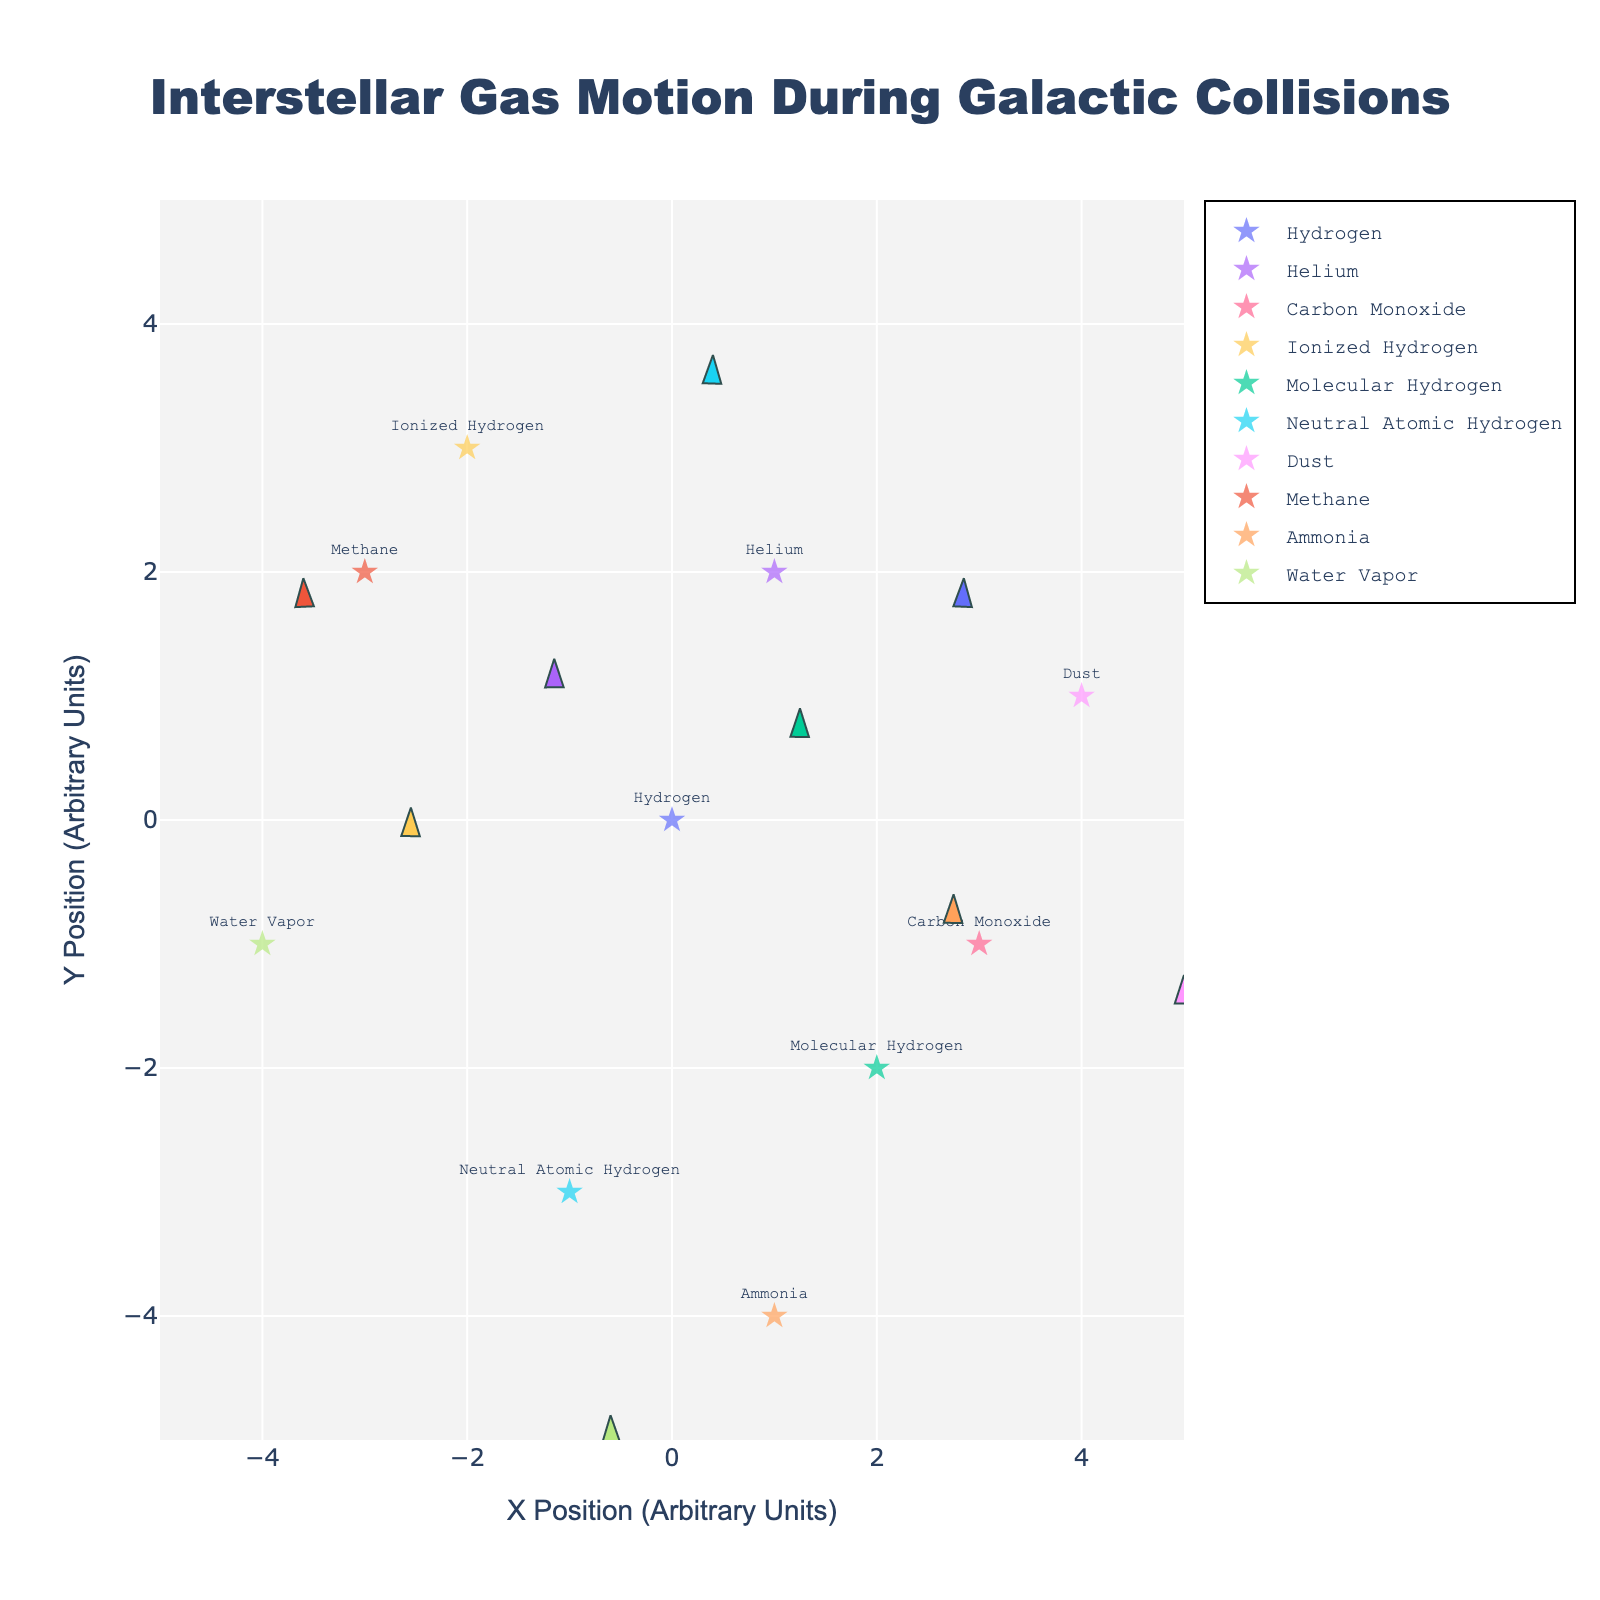What is the title of the figure? The title is located at the top center of the figure, which provides a brief description of the content being displayed. The title reads "Interstellar Gas Motion During Galactic Collisions."
Answer: Interstellar Gas Motion During Galactic Collisions How many distinct gas types are represented in the figure? Each gas type is labeled and represented by markers and arrows on the plot. Counting the unique gas types from the labels, we find eight distinct types: Hydrogen, Helium, Carbon Monoxide, Ionized Hydrogen, Molecular Hydrogen, Neutral Atomic Hydrogen, Dust, Methane, Ammonia, and Water Vapor.
Answer: 10 Where is the Ionized Hydrogen located in the plot? To find the location of Ionized Hydrogen, look for the label "Ionized Hydrogen" on the plot. Ionized Hydrogen is located at coordinates (-2, 3).
Answer: (-2, 3) Which gas type has the largest magnitude of motion and what is its value? Each gas type's magnitude is indicated by the length of the arrow (representing the vector) and the value provided. The largest magnitude of motion can be found by comparing these values. The largest magnitude is associated with Carbon Monoxide, with a magnitude of 4.0.
Answer: Carbon Monoxide, 4.0 What are the X and Y ranges of the plot? The X and Y ranges of the plot can be found by examining the axes' limits. Both the X and Y axes range from -5 to 5, based on the axis specifications.
Answer: -5 to 5 Which gas type shows a negative X motion but positive Y motion? To find the gas type with negative X motion and positive Y motion, examine the arrows' directions. Helium has a negative X component (-1.2) and a positive Y component (3.5), indicating this motion.
Answer: Helium Compare the velocities (u and v components) of Methane and Water Vapor. Which one has a greater horizontal (u) velocity? To compare velocities, look at the u components for Methane and Water Vapor. Methane has a u component of 3.7, while Water Vapor has a u component of 2.9. Methane has the greater horizontal velocity.
Answer: Methane Find the average magnitude of motion for all gas types. To calculate the average magnitude, sum all the magnitudes and divide by the number of gas types. Sum = 3.1 + 3.7 + 4.0 + 3.8 + 3.2 + 3.7 + 3.0 + 3.9 + 3.2 + 3.6 = 35.2. Number of gas types = 10. Therefore, average magnitude = 35.2 / 10 = 3.52.
Answer: 3.52 Which gas type is moving in the direction opposite to Ammonia? Ammonia has a motion vector of (-1.8, -2.7). To find the opposite direction, we look for a gas type with a positive X (u) and positive Y (v) motion. Hydrogen has a motion vector (2.5, 1.8), moving in approximately the opposite direction.
Answer: Hydrogen 